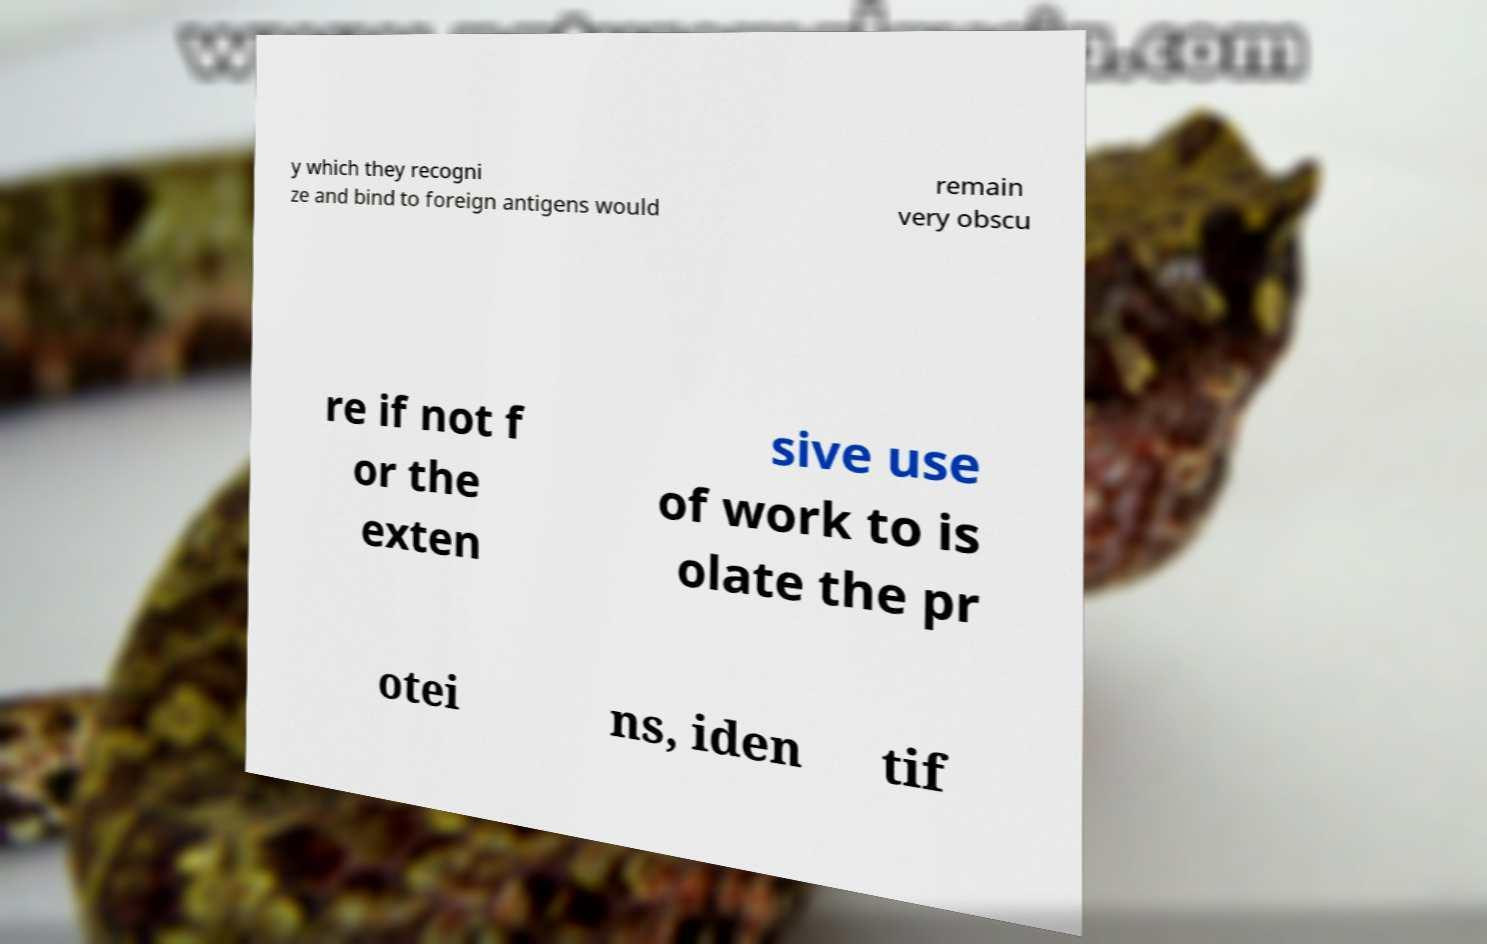There's text embedded in this image that I need extracted. Can you transcribe it verbatim? y which they recogni ze and bind to foreign antigens would remain very obscu re if not f or the exten sive use of work to is olate the pr otei ns, iden tif 